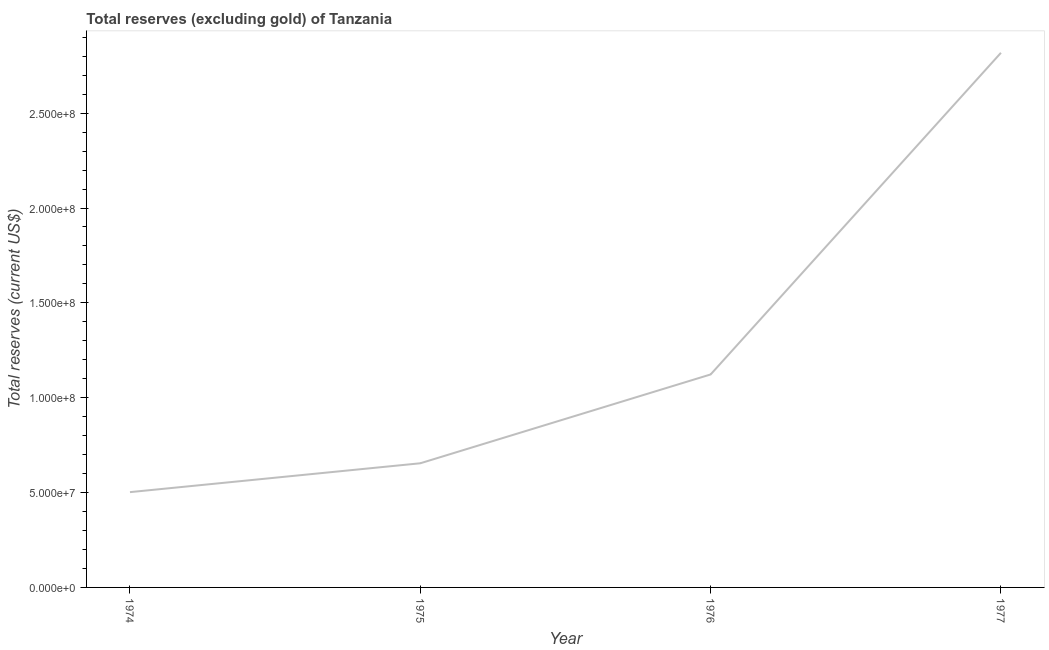What is the total reserves (excluding gold) in 1974?
Your answer should be compact. 5.02e+07. Across all years, what is the maximum total reserves (excluding gold)?
Your answer should be compact. 2.82e+08. Across all years, what is the minimum total reserves (excluding gold)?
Provide a succinct answer. 5.02e+07. In which year was the total reserves (excluding gold) minimum?
Ensure brevity in your answer.  1974. What is the sum of the total reserves (excluding gold)?
Give a very brief answer. 5.10e+08. What is the difference between the total reserves (excluding gold) in 1974 and 1977?
Provide a succinct answer. -2.32e+08. What is the average total reserves (excluding gold) per year?
Make the answer very short. 1.27e+08. What is the median total reserves (excluding gold)?
Make the answer very short. 8.89e+07. In how many years, is the total reserves (excluding gold) greater than 130000000 US$?
Ensure brevity in your answer.  1. What is the ratio of the total reserves (excluding gold) in 1974 to that in 1976?
Your answer should be compact. 0.45. What is the difference between the highest and the second highest total reserves (excluding gold)?
Keep it short and to the point. 1.70e+08. Is the sum of the total reserves (excluding gold) in 1974 and 1975 greater than the maximum total reserves (excluding gold) across all years?
Offer a terse response. No. What is the difference between the highest and the lowest total reserves (excluding gold)?
Your response must be concise. 2.32e+08. In how many years, is the total reserves (excluding gold) greater than the average total reserves (excluding gold) taken over all years?
Ensure brevity in your answer.  1. Does the graph contain any zero values?
Keep it short and to the point. No. Does the graph contain grids?
Offer a very short reply. No. What is the title of the graph?
Your answer should be compact. Total reserves (excluding gold) of Tanzania. What is the label or title of the X-axis?
Make the answer very short. Year. What is the label or title of the Y-axis?
Provide a succinct answer. Total reserves (current US$). What is the Total reserves (current US$) of 1974?
Keep it short and to the point. 5.02e+07. What is the Total reserves (current US$) of 1975?
Provide a short and direct response. 6.54e+07. What is the Total reserves (current US$) of 1976?
Provide a succinct answer. 1.12e+08. What is the Total reserves (current US$) of 1977?
Provide a short and direct response. 2.82e+08. What is the difference between the Total reserves (current US$) in 1974 and 1975?
Ensure brevity in your answer.  -1.52e+07. What is the difference between the Total reserves (current US$) in 1974 and 1976?
Your answer should be compact. -6.20e+07. What is the difference between the Total reserves (current US$) in 1974 and 1977?
Give a very brief answer. -2.32e+08. What is the difference between the Total reserves (current US$) in 1975 and 1976?
Make the answer very short. -4.68e+07. What is the difference between the Total reserves (current US$) in 1975 and 1977?
Offer a terse response. -2.16e+08. What is the difference between the Total reserves (current US$) in 1976 and 1977?
Your response must be concise. -1.70e+08. What is the ratio of the Total reserves (current US$) in 1974 to that in 1975?
Your response must be concise. 0.77. What is the ratio of the Total reserves (current US$) in 1974 to that in 1976?
Offer a terse response. 0.45. What is the ratio of the Total reserves (current US$) in 1974 to that in 1977?
Keep it short and to the point. 0.18. What is the ratio of the Total reserves (current US$) in 1975 to that in 1976?
Offer a terse response. 0.58. What is the ratio of the Total reserves (current US$) in 1975 to that in 1977?
Your answer should be very brief. 0.23. What is the ratio of the Total reserves (current US$) in 1976 to that in 1977?
Ensure brevity in your answer.  0.4. 